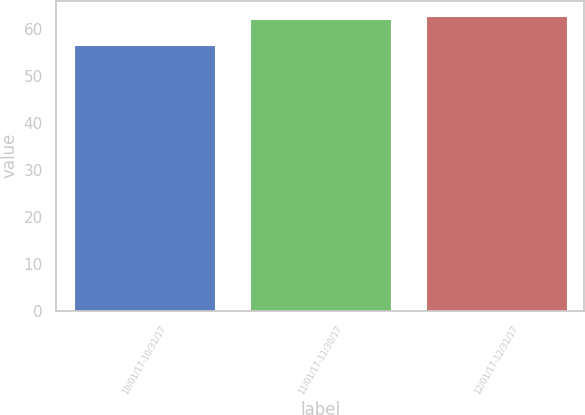<chart> <loc_0><loc_0><loc_500><loc_500><bar_chart><fcel>10/01/17-10/31/17<fcel>11/01/17-11/30/17<fcel>12/01/17-12/31/17<nl><fcel>56.43<fcel>62.03<fcel>62.78<nl></chart> 